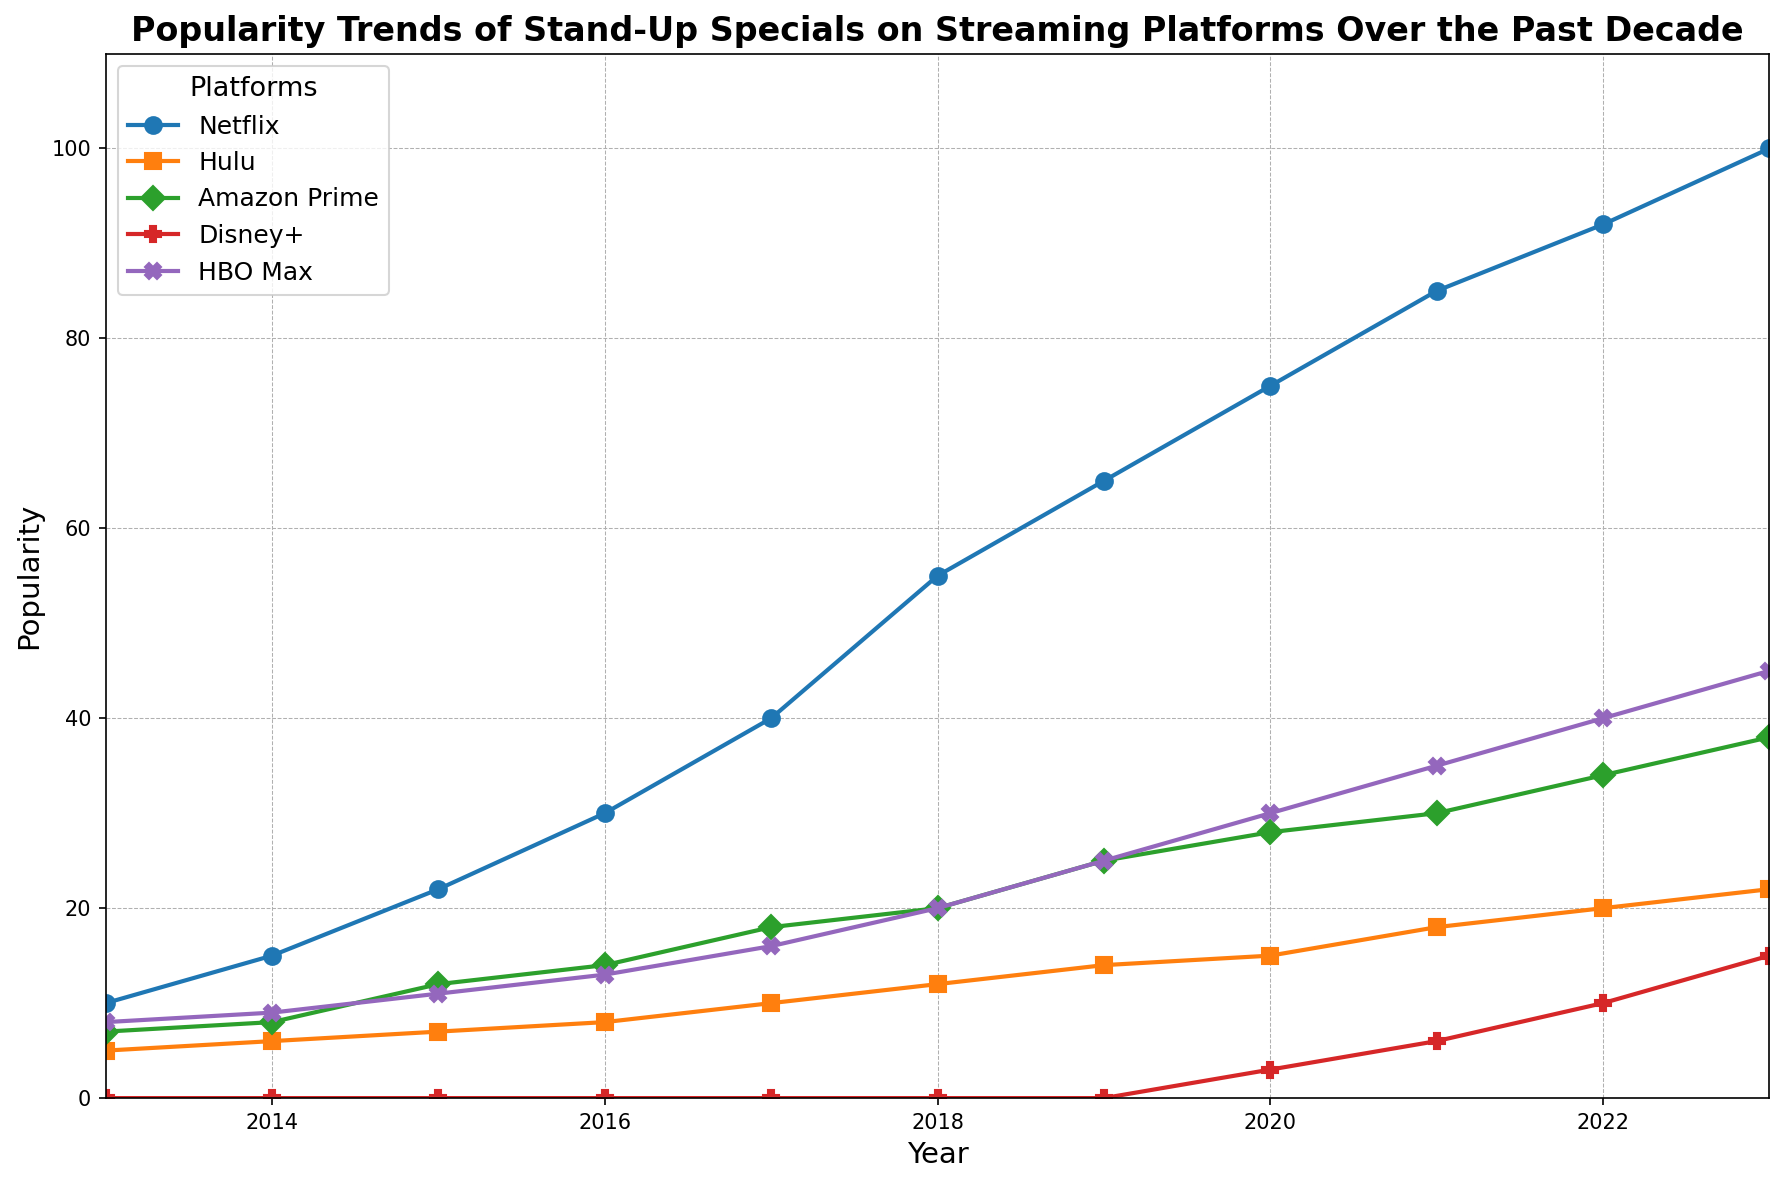How does the popularity of Netflix's stand-up specials in 2013 compare to 2023? We compare the values for Netflix in the years 2013 and 2023. The popularity was 10 in 2013 and 100 in 2023, showing a significant increase.
Answer: 90 increase Which platform had the highest increase in popularity between 2019 and 2023? By comparing the values for each platform in 2019 and 2023, we find the differences: Netflix (35), Hulu (8), Amazon Prime (13), Disney+ (15), and HBO Max (20). HBO Max had the highest increase.
Answer: HBO Max What were the two most popular platforms in 2023? The 2023 data shows Netflix with a popularity of 100 and HBO Max with 45, which are the two highest values among the platforms.
Answer: Netflix and HBO Max Which year did Disney+ first start showing popularity data? Disney+ first shows data in the year 2020 with a popularity of 3, indicating its debut.
Answer: 2020 What is the average change in popularity per year for Amazon Prime between 2013 and 2023? The overall change from 2013 (7) to 2023 (38) is 31. Over 10 years, the average change per year is 31 / 10 = 3.1.
Answer: 3.1 How does Hulu's popularity trend compare to Amazon Prime's over the decade? Hulu and Amazon Prime both have upward trends, but Amazon Prime shows a higher overall increase (31) compared to Hulu (17) from 2013 to 2023.
Answer: Amazon Prime increased more By how much did Netflix's popularity grow from 2016 to 2020? Netflix's popularity in 2016 was 30 and in 2020 it was 75. The growth is 75 - 30 = 45.
Answer: 45 What can be inferred about Disney+ comparing its 2021 and 2023 popularity? Disney+ rose from a popularity of 6 in 2021 to 15 in 2023, indicating growth in stand-up special popularity.
Answer: increased by 9 Which platform's popularity remained the lowest in 2020 and what was its value? Comparing 2020 values, Disney+ had the lowest popularity with a value of 3.
Answer: Disney+, 3 Summing the popularity values of all platforms in 2022, what is the total? Summing the values: Netflix (92) + Hulu (20) + Amazon Prime (34) + Disney+ (10) + HBO Max (40) = 196.
Answer: 196 